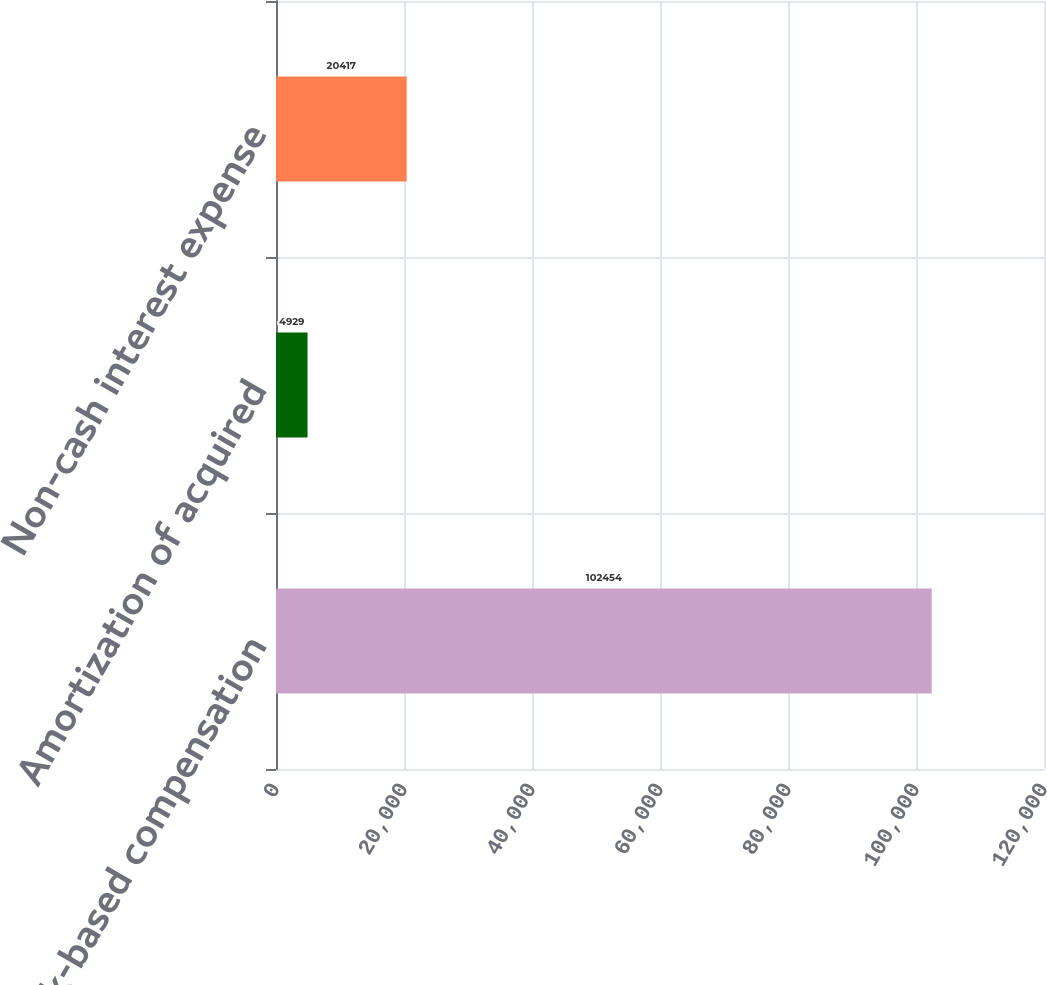Convert chart. <chart><loc_0><loc_0><loc_500><loc_500><bar_chart><fcel>Stock-based compensation<fcel>Amortization of acquired<fcel>Non-cash interest expense<nl><fcel>102454<fcel>4929<fcel>20417<nl></chart> 